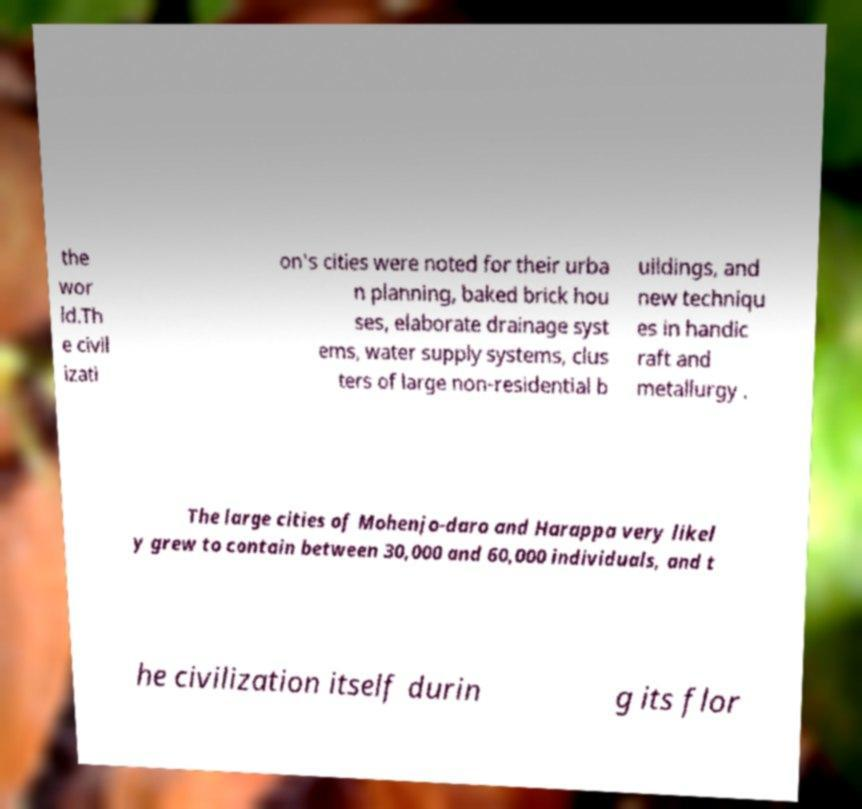Please identify and transcribe the text found in this image. the wor ld.Th e civil izati on's cities were noted for their urba n planning, baked brick hou ses, elaborate drainage syst ems, water supply systems, clus ters of large non-residential b uildings, and new techniqu es in handic raft and metallurgy . The large cities of Mohenjo-daro and Harappa very likel y grew to contain between 30,000 and 60,000 individuals, and t he civilization itself durin g its flor 